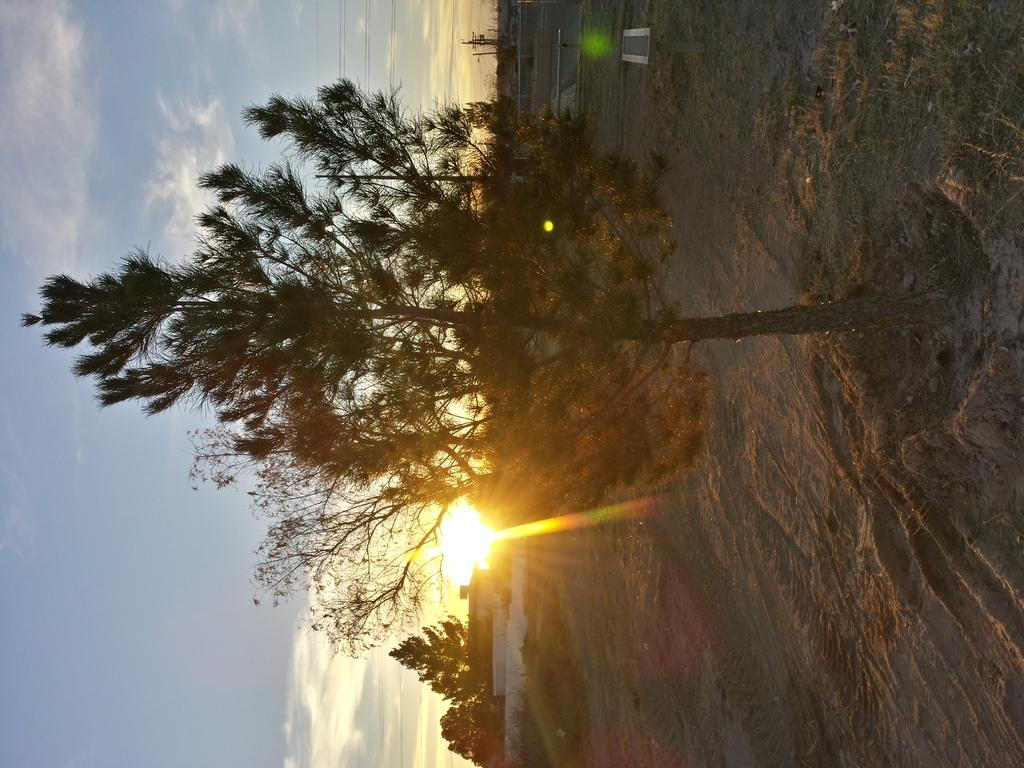What type of natural elements can be seen in the image? There are trees in the image. What man-made structures are present in the image? There are houses in the image. What type of infrastructure can be seen in the image? There are electric wires in the image. What is visible in the sky in the image? There are clouds visible in the sky. Where is the faucet located in the image? There is no faucet present in the image. How many people are in the room in the image? There is no room present in the image, so it is not possible to determine the number of people. 